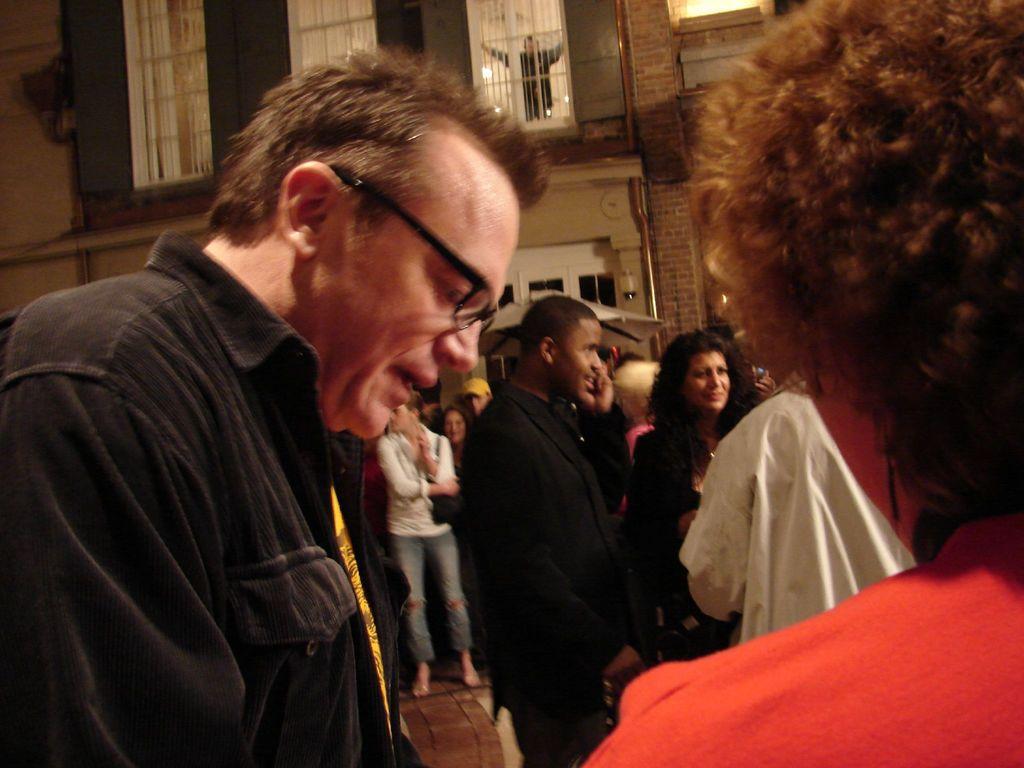How would you summarize this image in a sentence or two? In this image there are people standing, in the background there is a building. 